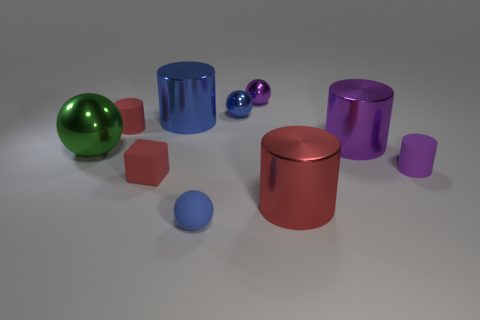There is a matte sphere; does it have the same color as the large cylinder that is left of the red shiny cylinder?
Ensure brevity in your answer.  Yes. What size is the green metal thing behind the rubber cylinder that is in front of the large purple metal object?
Offer a very short reply. Large. What number of objects are either big red metal cylinders or tiny blue balls behind the big green metal thing?
Ensure brevity in your answer.  2. Does the tiny blue shiny thing on the left side of the tiny purple rubber cylinder have the same shape as the large green metallic object?
Keep it short and to the point. Yes. There is a big metallic sphere that is in front of the big shiny cylinder that is on the left side of the blue matte sphere; how many purple rubber cylinders are to the right of it?
Offer a terse response. 1. How many objects are small purple matte objects or small green shiny objects?
Keep it short and to the point. 1. There is a large red thing; is its shape the same as the red matte thing behind the tiny block?
Provide a short and direct response. Yes. What shape is the rubber object to the right of the big red shiny thing?
Provide a short and direct response. Cylinder. Is the shape of the small blue metal thing the same as the big red thing?
Provide a succinct answer. No. There is another purple object that is the same shape as the purple matte thing; what size is it?
Your response must be concise. Large. 